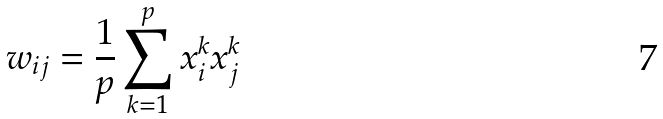<formula> <loc_0><loc_0><loc_500><loc_500>w _ { i j } = \frac { 1 } { p } \sum _ { k = 1 } ^ { p } x _ { i } ^ { k } x _ { j } ^ { k }</formula> 